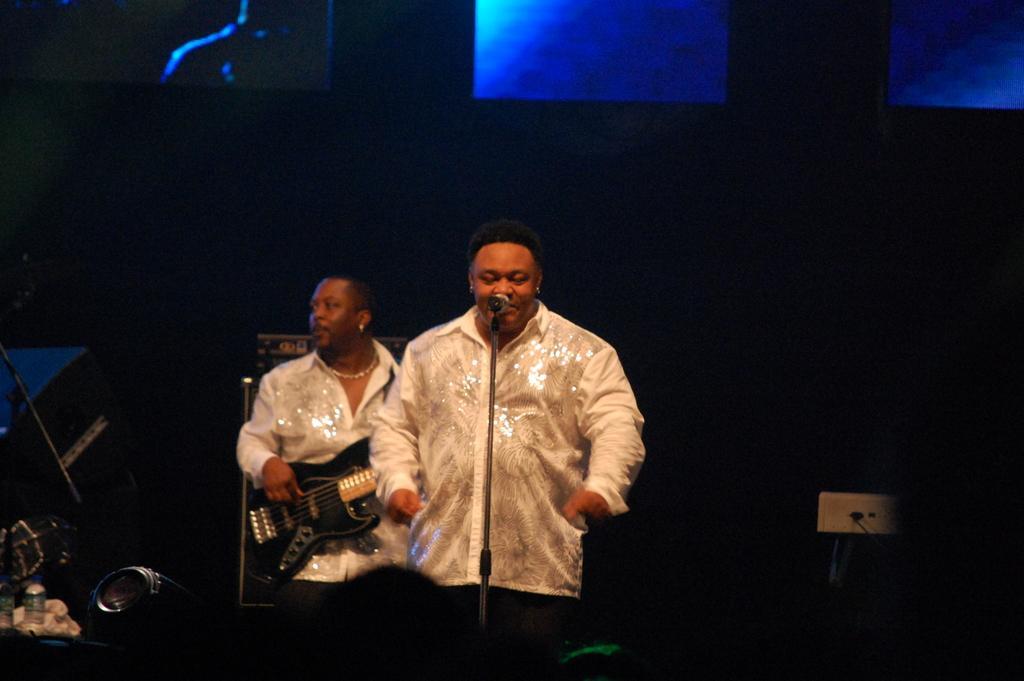In one or two sentences, can you explain what this image depicts? There are two persons standing. One person is singing a song and the other person is playing guitar. 